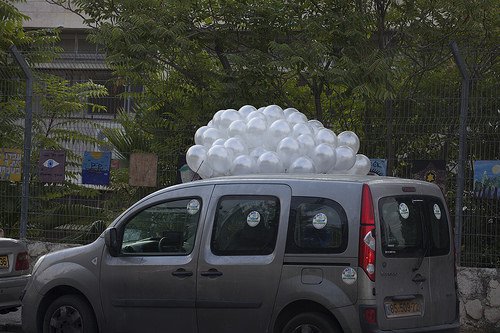<image>
Is there a balloons on the car? Yes. Looking at the image, I can see the balloons is positioned on top of the car, with the car providing support. Is there a balloon on the car? Yes. Looking at the image, I can see the balloon is positioned on top of the car, with the car providing support. Where is the car in relation to the balloons? Is it to the left of the balloons? No. The car is not to the left of the balloons. From this viewpoint, they have a different horizontal relationship. Is the car under the ballon? Yes. The car is positioned underneath the ballon, with the ballon above it in the vertical space. 